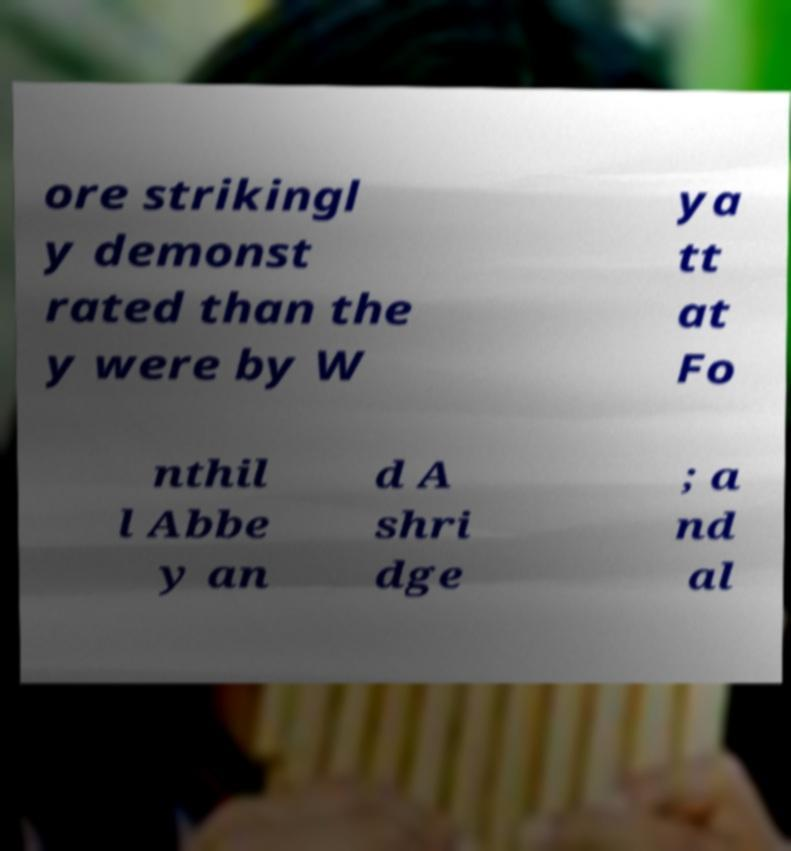Please read and relay the text visible in this image. What does it say? ore strikingl y demonst rated than the y were by W ya tt at Fo nthil l Abbe y an d A shri dge ; a nd al 